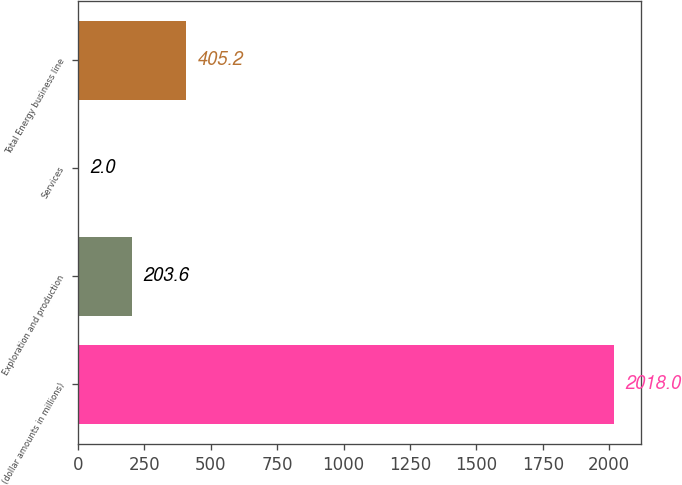<chart> <loc_0><loc_0><loc_500><loc_500><bar_chart><fcel>(dollar amounts in millions)<fcel>Exploration and production<fcel>Services<fcel>Total Energy business line<nl><fcel>2018<fcel>203.6<fcel>2<fcel>405.2<nl></chart> 